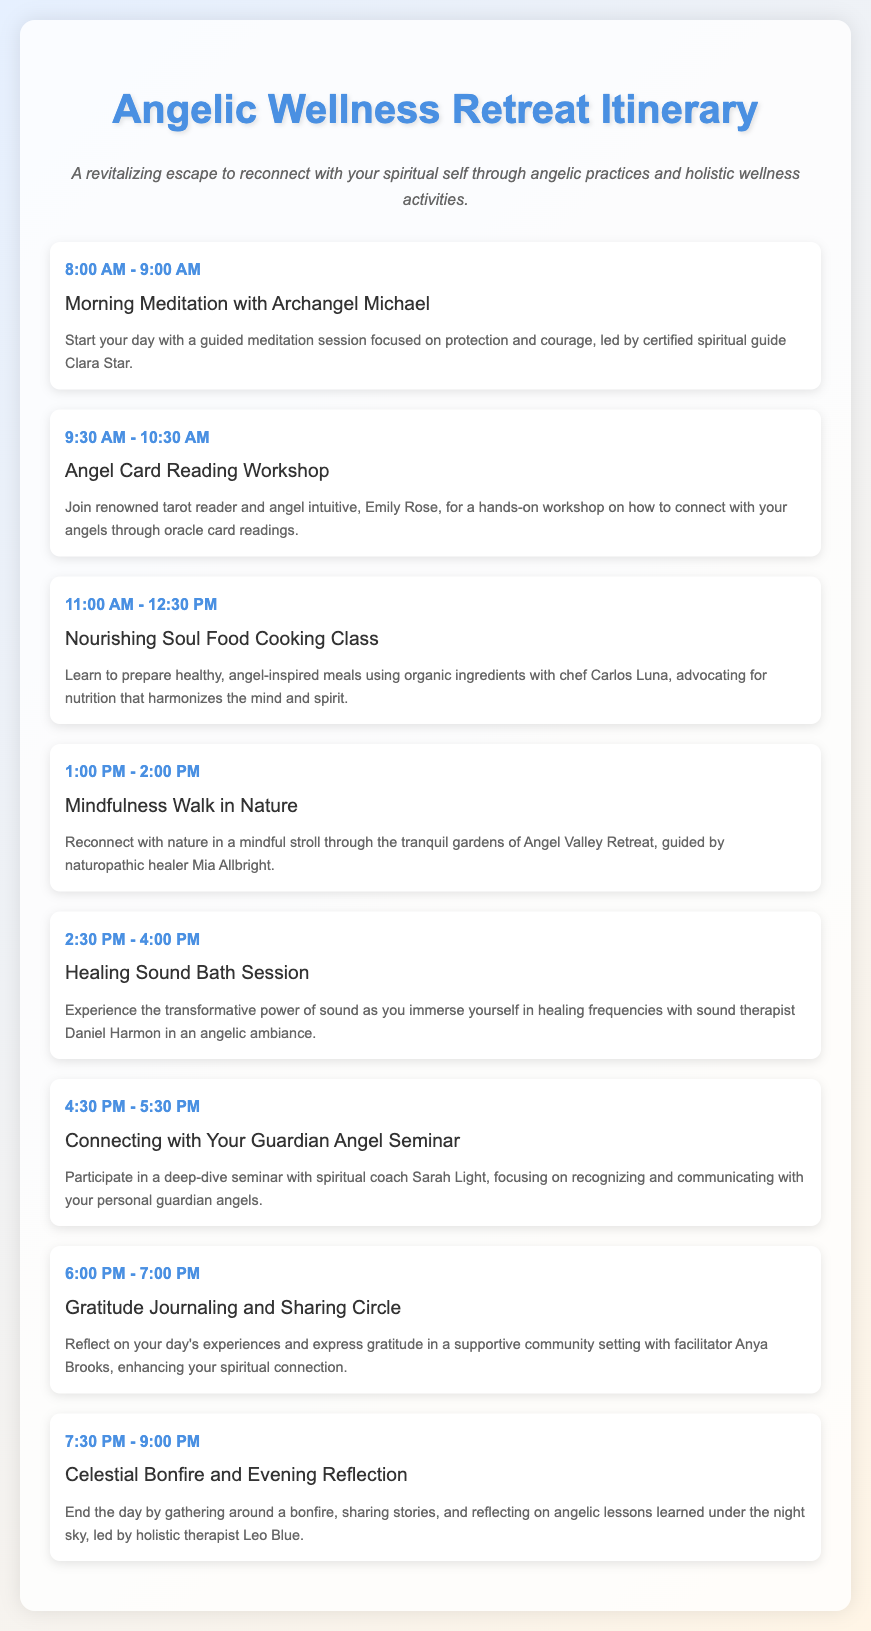What time does the Morning Meditation start? The Morning Meditation starts at 8:00 AM.
Answer: 8:00 AM Who leads the Healing Sound Bath Session? The Healing Sound Bath Session is led by sound therapist Daniel Harmon.
Answer: Daniel Harmon What activity is scheduled at 2:30 PM? The activity scheduled at 2:30 PM is the Healing Sound Bath Session.
Answer: Healing Sound Bath Session How long is the Connecting with Your Guardian Angel Seminar? The Connecting with Your Guardian Angel Seminar is 1 hour long.
Answer: 1 hour What is the focus of the Angel Card Reading Workshop? The focus of the Angel Card Reading Workshop is on connecting with your angels through oracle card readings.
Answer: Connecting with your angels through oracle card readings Who facilitates the Gratitude Journaling and Sharing Circle? The Gratitude Journaling and Sharing Circle is facilitated by Anya Brooks.
Answer: Anya Brooks What type of cooking class is offered during the retreat? The cooking class offered is a Nourishing Soul Food Cooking Class.
Answer: Nourishing Soul Food Cooking Class What is the name of the retreat? The name of the retreat is Angel Valley Retreat.
Answer: Angel Valley Retreat What will participants experience during the Celestial Bonfire session? Participants will share stories and reflect on angelic lessons learned under the night sky during the Celestial Bonfire session.
Answer: Share stories and reflect on angelic lessons learned under the night sky 